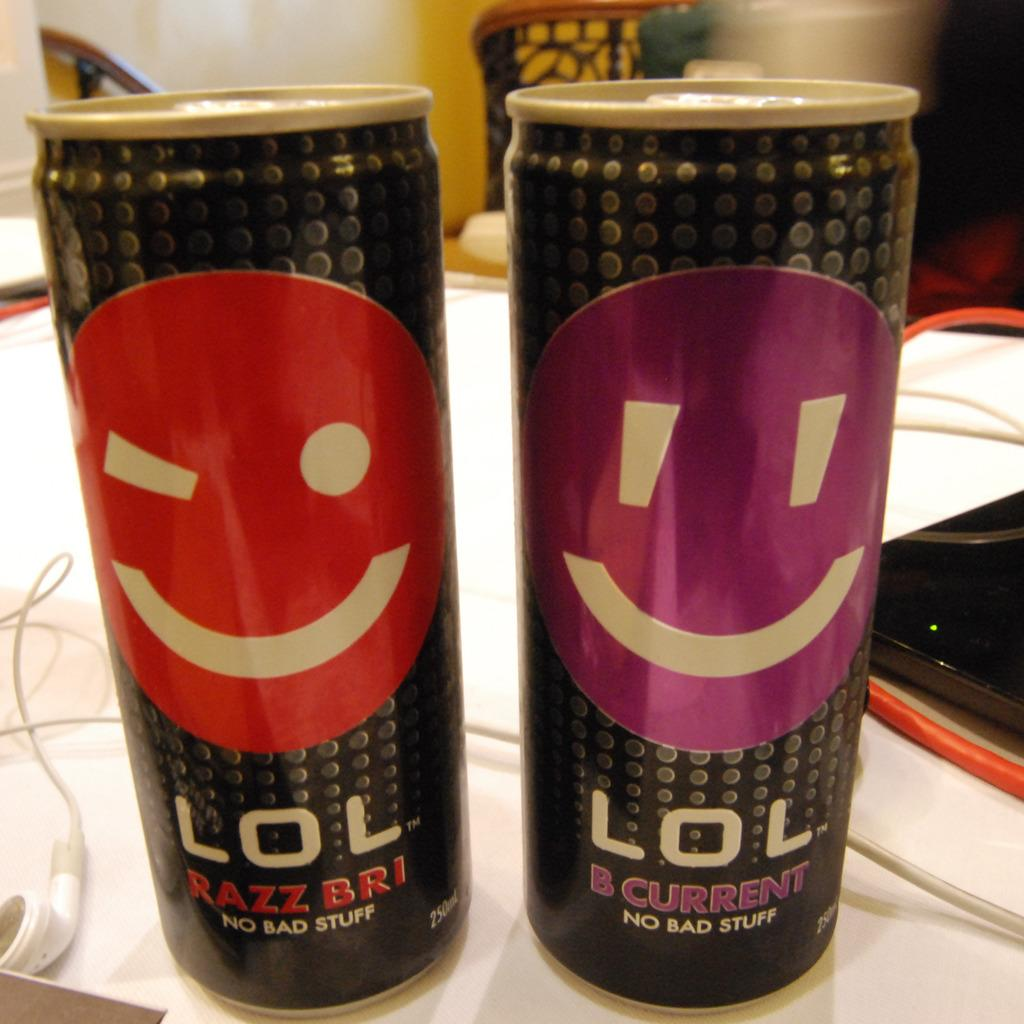<image>
Provide a brief description of the given image. Two LOL drinks in cans sit next to each other on a desk. 